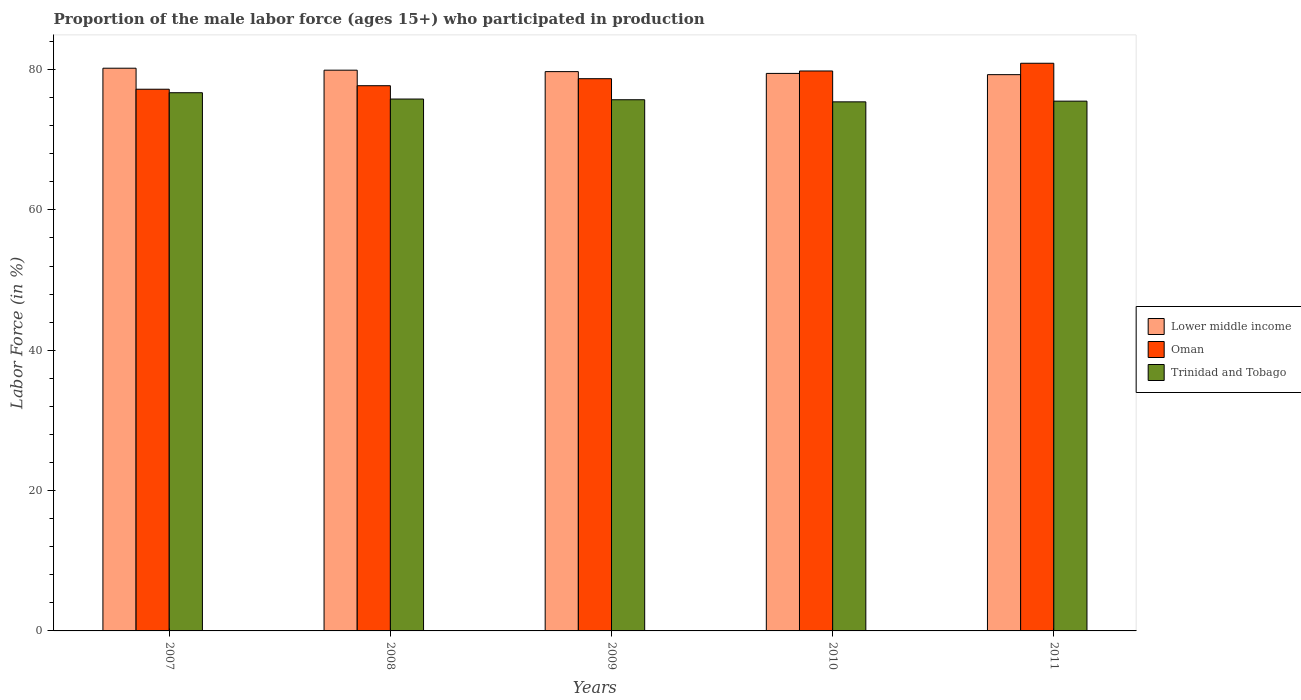How many different coloured bars are there?
Provide a succinct answer. 3. How many groups of bars are there?
Your response must be concise. 5. In how many cases, is the number of bars for a given year not equal to the number of legend labels?
Your response must be concise. 0. What is the proportion of the male labor force who participated in production in Trinidad and Tobago in 2009?
Give a very brief answer. 75.7. Across all years, what is the maximum proportion of the male labor force who participated in production in Trinidad and Tobago?
Offer a very short reply. 76.7. Across all years, what is the minimum proportion of the male labor force who participated in production in Lower middle income?
Provide a succinct answer. 79.28. In which year was the proportion of the male labor force who participated in production in Lower middle income maximum?
Make the answer very short. 2007. In which year was the proportion of the male labor force who participated in production in Trinidad and Tobago minimum?
Your response must be concise. 2010. What is the total proportion of the male labor force who participated in production in Trinidad and Tobago in the graph?
Give a very brief answer. 379.1. What is the difference between the proportion of the male labor force who participated in production in Oman in 2007 and that in 2011?
Offer a terse response. -3.7. What is the average proportion of the male labor force who participated in production in Oman per year?
Your answer should be compact. 78.86. In the year 2010, what is the difference between the proportion of the male labor force who participated in production in Lower middle income and proportion of the male labor force who participated in production in Trinidad and Tobago?
Provide a succinct answer. 4.05. What is the ratio of the proportion of the male labor force who participated in production in Oman in 2009 to that in 2010?
Provide a succinct answer. 0.99. Is the proportion of the male labor force who participated in production in Lower middle income in 2008 less than that in 2010?
Provide a short and direct response. No. What is the difference between the highest and the second highest proportion of the male labor force who participated in production in Trinidad and Tobago?
Provide a succinct answer. 0.9. What is the difference between the highest and the lowest proportion of the male labor force who participated in production in Trinidad and Tobago?
Make the answer very short. 1.3. In how many years, is the proportion of the male labor force who participated in production in Lower middle income greater than the average proportion of the male labor force who participated in production in Lower middle income taken over all years?
Your response must be concise. 3. Is the sum of the proportion of the male labor force who participated in production in Trinidad and Tobago in 2009 and 2011 greater than the maximum proportion of the male labor force who participated in production in Lower middle income across all years?
Provide a short and direct response. Yes. What does the 1st bar from the left in 2008 represents?
Keep it short and to the point. Lower middle income. What does the 3rd bar from the right in 2008 represents?
Your answer should be very brief. Lower middle income. Is it the case that in every year, the sum of the proportion of the male labor force who participated in production in Trinidad and Tobago and proportion of the male labor force who participated in production in Lower middle income is greater than the proportion of the male labor force who participated in production in Oman?
Keep it short and to the point. Yes. Are all the bars in the graph horizontal?
Offer a very short reply. No. How many years are there in the graph?
Your answer should be very brief. 5. What is the difference between two consecutive major ticks on the Y-axis?
Keep it short and to the point. 20. Does the graph contain any zero values?
Provide a short and direct response. No. Does the graph contain grids?
Your answer should be compact. No. How many legend labels are there?
Make the answer very short. 3. How are the legend labels stacked?
Make the answer very short. Vertical. What is the title of the graph?
Your response must be concise. Proportion of the male labor force (ages 15+) who participated in production. What is the Labor Force (in %) in Lower middle income in 2007?
Offer a terse response. 80.19. What is the Labor Force (in %) of Oman in 2007?
Your answer should be very brief. 77.2. What is the Labor Force (in %) of Trinidad and Tobago in 2007?
Ensure brevity in your answer.  76.7. What is the Labor Force (in %) in Lower middle income in 2008?
Keep it short and to the point. 79.91. What is the Labor Force (in %) in Oman in 2008?
Ensure brevity in your answer.  77.7. What is the Labor Force (in %) of Trinidad and Tobago in 2008?
Ensure brevity in your answer.  75.8. What is the Labor Force (in %) of Lower middle income in 2009?
Your response must be concise. 79.71. What is the Labor Force (in %) of Oman in 2009?
Offer a very short reply. 78.7. What is the Labor Force (in %) in Trinidad and Tobago in 2009?
Make the answer very short. 75.7. What is the Labor Force (in %) in Lower middle income in 2010?
Provide a short and direct response. 79.45. What is the Labor Force (in %) in Oman in 2010?
Provide a short and direct response. 79.8. What is the Labor Force (in %) in Trinidad and Tobago in 2010?
Your response must be concise. 75.4. What is the Labor Force (in %) of Lower middle income in 2011?
Keep it short and to the point. 79.28. What is the Labor Force (in %) of Oman in 2011?
Your response must be concise. 80.9. What is the Labor Force (in %) of Trinidad and Tobago in 2011?
Provide a short and direct response. 75.5. Across all years, what is the maximum Labor Force (in %) of Lower middle income?
Offer a terse response. 80.19. Across all years, what is the maximum Labor Force (in %) in Oman?
Provide a short and direct response. 80.9. Across all years, what is the maximum Labor Force (in %) of Trinidad and Tobago?
Your answer should be compact. 76.7. Across all years, what is the minimum Labor Force (in %) in Lower middle income?
Provide a short and direct response. 79.28. Across all years, what is the minimum Labor Force (in %) in Oman?
Provide a short and direct response. 77.2. Across all years, what is the minimum Labor Force (in %) in Trinidad and Tobago?
Provide a short and direct response. 75.4. What is the total Labor Force (in %) of Lower middle income in the graph?
Offer a terse response. 398.54. What is the total Labor Force (in %) of Oman in the graph?
Give a very brief answer. 394.3. What is the total Labor Force (in %) of Trinidad and Tobago in the graph?
Offer a very short reply. 379.1. What is the difference between the Labor Force (in %) in Lower middle income in 2007 and that in 2008?
Offer a terse response. 0.28. What is the difference between the Labor Force (in %) in Oman in 2007 and that in 2008?
Provide a short and direct response. -0.5. What is the difference between the Labor Force (in %) in Trinidad and Tobago in 2007 and that in 2008?
Offer a terse response. 0.9. What is the difference between the Labor Force (in %) in Lower middle income in 2007 and that in 2009?
Your response must be concise. 0.48. What is the difference between the Labor Force (in %) in Lower middle income in 2007 and that in 2010?
Ensure brevity in your answer.  0.74. What is the difference between the Labor Force (in %) in Oman in 2007 and that in 2010?
Provide a succinct answer. -2.6. What is the difference between the Labor Force (in %) in Trinidad and Tobago in 2007 and that in 2010?
Ensure brevity in your answer.  1.3. What is the difference between the Labor Force (in %) in Lower middle income in 2007 and that in 2011?
Offer a terse response. 0.92. What is the difference between the Labor Force (in %) in Oman in 2007 and that in 2011?
Provide a short and direct response. -3.7. What is the difference between the Labor Force (in %) of Lower middle income in 2008 and that in 2009?
Your response must be concise. 0.2. What is the difference between the Labor Force (in %) of Oman in 2008 and that in 2009?
Provide a succinct answer. -1. What is the difference between the Labor Force (in %) of Trinidad and Tobago in 2008 and that in 2009?
Your response must be concise. 0.1. What is the difference between the Labor Force (in %) in Lower middle income in 2008 and that in 2010?
Your answer should be compact. 0.46. What is the difference between the Labor Force (in %) of Oman in 2008 and that in 2010?
Offer a very short reply. -2.1. What is the difference between the Labor Force (in %) of Lower middle income in 2008 and that in 2011?
Your answer should be compact. 0.64. What is the difference between the Labor Force (in %) of Lower middle income in 2009 and that in 2010?
Offer a very short reply. 0.26. What is the difference between the Labor Force (in %) of Trinidad and Tobago in 2009 and that in 2010?
Provide a short and direct response. 0.3. What is the difference between the Labor Force (in %) of Lower middle income in 2009 and that in 2011?
Your response must be concise. 0.43. What is the difference between the Labor Force (in %) in Oman in 2009 and that in 2011?
Give a very brief answer. -2.2. What is the difference between the Labor Force (in %) of Trinidad and Tobago in 2009 and that in 2011?
Ensure brevity in your answer.  0.2. What is the difference between the Labor Force (in %) in Lower middle income in 2010 and that in 2011?
Offer a very short reply. 0.18. What is the difference between the Labor Force (in %) in Lower middle income in 2007 and the Labor Force (in %) in Oman in 2008?
Make the answer very short. 2.49. What is the difference between the Labor Force (in %) of Lower middle income in 2007 and the Labor Force (in %) of Trinidad and Tobago in 2008?
Your response must be concise. 4.39. What is the difference between the Labor Force (in %) of Oman in 2007 and the Labor Force (in %) of Trinidad and Tobago in 2008?
Make the answer very short. 1.4. What is the difference between the Labor Force (in %) in Lower middle income in 2007 and the Labor Force (in %) in Oman in 2009?
Keep it short and to the point. 1.49. What is the difference between the Labor Force (in %) in Lower middle income in 2007 and the Labor Force (in %) in Trinidad and Tobago in 2009?
Your answer should be very brief. 4.49. What is the difference between the Labor Force (in %) of Lower middle income in 2007 and the Labor Force (in %) of Oman in 2010?
Offer a very short reply. 0.39. What is the difference between the Labor Force (in %) of Lower middle income in 2007 and the Labor Force (in %) of Trinidad and Tobago in 2010?
Provide a short and direct response. 4.79. What is the difference between the Labor Force (in %) of Lower middle income in 2007 and the Labor Force (in %) of Oman in 2011?
Keep it short and to the point. -0.71. What is the difference between the Labor Force (in %) of Lower middle income in 2007 and the Labor Force (in %) of Trinidad and Tobago in 2011?
Your answer should be very brief. 4.69. What is the difference between the Labor Force (in %) in Oman in 2007 and the Labor Force (in %) in Trinidad and Tobago in 2011?
Provide a succinct answer. 1.7. What is the difference between the Labor Force (in %) in Lower middle income in 2008 and the Labor Force (in %) in Oman in 2009?
Give a very brief answer. 1.21. What is the difference between the Labor Force (in %) of Lower middle income in 2008 and the Labor Force (in %) of Trinidad and Tobago in 2009?
Give a very brief answer. 4.21. What is the difference between the Labor Force (in %) of Oman in 2008 and the Labor Force (in %) of Trinidad and Tobago in 2009?
Your answer should be very brief. 2. What is the difference between the Labor Force (in %) of Lower middle income in 2008 and the Labor Force (in %) of Oman in 2010?
Offer a terse response. 0.11. What is the difference between the Labor Force (in %) of Lower middle income in 2008 and the Labor Force (in %) of Trinidad and Tobago in 2010?
Provide a succinct answer. 4.51. What is the difference between the Labor Force (in %) in Lower middle income in 2008 and the Labor Force (in %) in Oman in 2011?
Your answer should be compact. -0.99. What is the difference between the Labor Force (in %) of Lower middle income in 2008 and the Labor Force (in %) of Trinidad and Tobago in 2011?
Your answer should be very brief. 4.41. What is the difference between the Labor Force (in %) in Oman in 2008 and the Labor Force (in %) in Trinidad and Tobago in 2011?
Give a very brief answer. 2.2. What is the difference between the Labor Force (in %) in Lower middle income in 2009 and the Labor Force (in %) in Oman in 2010?
Provide a short and direct response. -0.09. What is the difference between the Labor Force (in %) of Lower middle income in 2009 and the Labor Force (in %) of Trinidad and Tobago in 2010?
Your answer should be compact. 4.31. What is the difference between the Labor Force (in %) in Oman in 2009 and the Labor Force (in %) in Trinidad and Tobago in 2010?
Provide a succinct answer. 3.3. What is the difference between the Labor Force (in %) of Lower middle income in 2009 and the Labor Force (in %) of Oman in 2011?
Ensure brevity in your answer.  -1.19. What is the difference between the Labor Force (in %) in Lower middle income in 2009 and the Labor Force (in %) in Trinidad and Tobago in 2011?
Give a very brief answer. 4.21. What is the difference between the Labor Force (in %) of Oman in 2009 and the Labor Force (in %) of Trinidad and Tobago in 2011?
Offer a terse response. 3.2. What is the difference between the Labor Force (in %) in Lower middle income in 2010 and the Labor Force (in %) in Oman in 2011?
Give a very brief answer. -1.45. What is the difference between the Labor Force (in %) in Lower middle income in 2010 and the Labor Force (in %) in Trinidad and Tobago in 2011?
Ensure brevity in your answer.  3.95. What is the average Labor Force (in %) of Lower middle income per year?
Make the answer very short. 79.71. What is the average Labor Force (in %) of Oman per year?
Your answer should be compact. 78.86. What is the average Labor Force (in %) in Trinidad and Tobago per year?
Ensure brevity in your answer.  75.82. In the year 2007, what is the difference between the Labor Force (in %) in Lower middle income and Labor Force (in %) in Oman?
Your response must be concise. 2.99. In the year 2007, what is the difference between the Labor Force (in %) in Lower middle income and Labor Force (in %) in Trinidad and Tobago?
Ensure brevity in your answer.  3.49. In the year 2008, what is the difference between the Labor Force (in %) of Lower middle income and Labor Force (in %) of Oman?
Your response must be concise. 2.21. In the year 2008, what is the difference between the Labor Force (in %) of Lower middle income and Labor Force (in %) of Trinidad and Tobago?
Provide a short and direct response. 4.11. In the year 2009, what is the difference between the Labor Force (in %) of Lower middle income and Labor Force (in %) of Oman?
Keep it short and to the point. 1.01. In the year 2009, what is the difference between the Labor Force (in %) in Lower middle income and Labor Force (in %) in Trinidad and Tobago?
Offer a terse response. 4.01. In the year 2009, what is the difference between the Labor Force (in %) in Oman and Labor Force (in %) in Trinidad and Tobago?
Give a very brief answer. 3. In the year 2010, what is the difference between the Labor Force (in %) in Lower middle income and Labor Force (in %) in Oman?
Give a very brief answer. -0.35. In the year 2010, what is the difference between the Labor Force (in %) in Lower middle income and Labor Force (in %) in Trinidad and Tobago?
Ensure brevity in your answer.  4.05. In the year 2011, what is the difference between the Labor Force (in %) of Lower middle income and Labor Force (in %) of Oman?
Offer a terse response. -1.62. In the year 2011, what is the difference between the Labor Force (in %) in Lower middle income and Labor Force (in %) in Trinidad and Tobago?
Make the answer very short. 3.78. In the year 2011, what is the difference between the Labor Force (in %) in Oman and Labor Force (in %) in Trinidad and Tobago?
Make the answer very short. 5.4. What is the ratio of the Labor Force (in %) of Oman in 2007 to that in 2008?
Provide a succinct answer. 0.99. What is the ratio of the Labor Force (in %) in Trinidad and Tobago in 2007 to that in 2008?
Ensure brevity in your answer.  1.01. What is the ratio of the Labor Force (in %) of Lower middle income in 2007 to that in 2009?
Your response must be concise. 1.01. What is the ratio of the Labor Force (in %) in Oman in 2007 to that in 2009?
Your answer should be very brief. 0.98. What is the ratio of the Labor Force (in %) of Trinidad and Tobago in 2007 to that in 2009?
Make the answer very short. 1.01. What is the ratio of the Labor Force (in %) in Lower middle income in 2007 to that in 2010?
Offer a very short reply. 1.01. What is the ratio of the Labor Force (in %) of Oman in 2007 to that in 2010?
Your answer should be very brief. 0.97. What is the ratio of the Labor Force (in %) in Trinidad and Tobago in 2007 to that in 2010?
Provide a short and direct response. 1.02. What is the ratio of the Labor Force (in %) of Lower middle income in 2007 to that in 2011?
Offer a very short reply. 1.01. What is the ratio of the Labor Force (in %) in Oman in 2007 to that in 2011?
Give a very brief answer. 0.95. What is the ratio of the Labor Force (in %) in Trinidad and Tobago in 2007 to that in 2011?
Make the answer very short. 1.02. What is the ratio of the Labor Force (in %) of Oman in 2008 to that in 2009?
Offer a terse response. 0.99. What is the ratio of the Labor Force (in %) of Lower middle income in 2008 to that in 2010?
Provide a succinct answer. 1.01. What is the ratio of the Labor Force (in %) of Oman in 2008 to that in 2010?
Make the answer very short. 0.97. What is the ratio of the Labor Force (in %) of Lower middle income in 2008 to that in 2011?
Keep it short and to the point. 1.01. What is the ratio of the Labor Force (in %) in Oman in 2008 to that in 2011?
Give a very brief answer. 0.96. What is the ratio of the Labor Force (in %) of Trinidad and Tobago in 2008 to that in 2011?
Offer a very short reply. 1. What is the ratio of the Labor Force (in %) of Oman in 2009 to that in 2010?
Your response must be concise. 0.99. What is the ratio of the Labor Force (in %) in Oman in 2009 to that in 2011?
Give a very brief answer. 0.97. What is the ratio of the Labor Force (in %) in Oman in 2010 to that in 2011?
Make the answer very short. 0.99. What is the difference between the highest and the second highest Labor Force (in %) of Lower middle income?
Make the answer very short. 0.28. What is the difference between the highest and the second highest Labor Force (in %) in Oman?
Offer a very short reply. 1.1. What is the difference between the highest and the lowest Labor Force (in %) of Lower middle income?
Your answer should be compact. 0.92. 